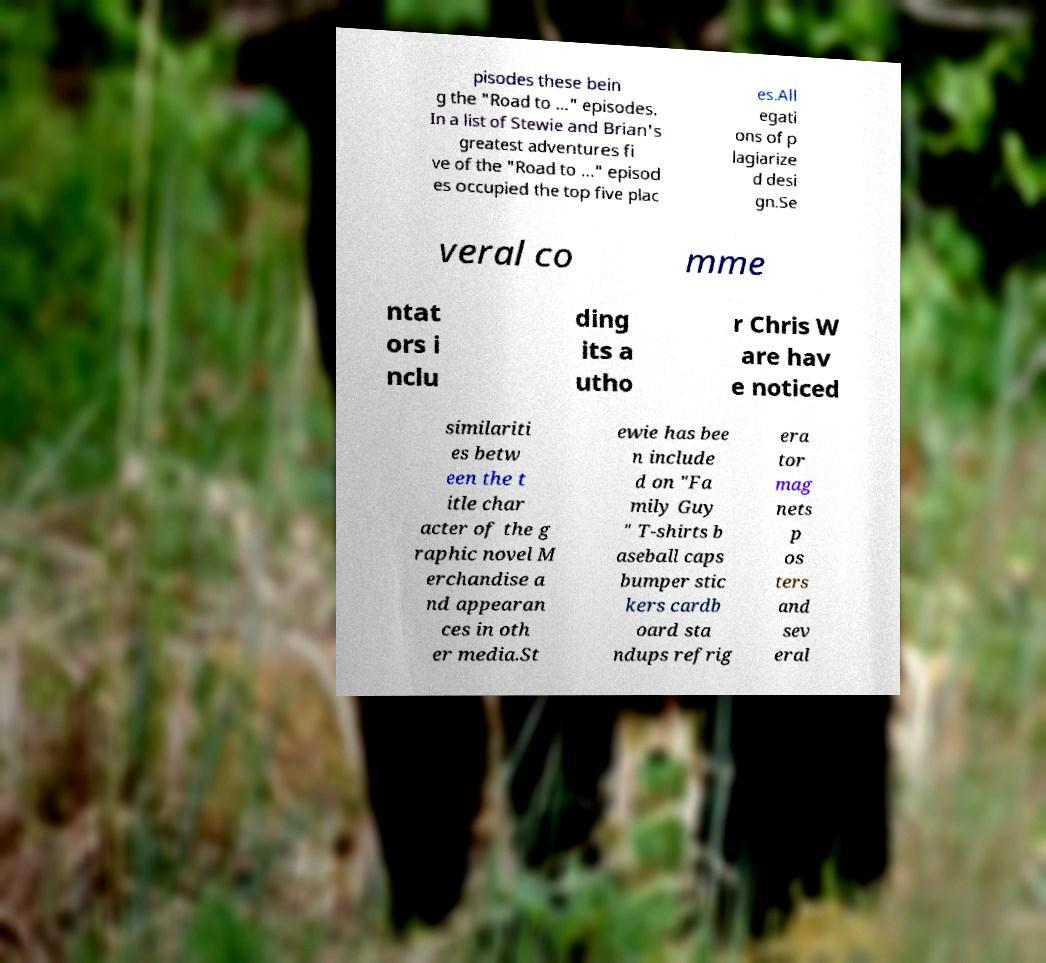What messages or text are displayed in this image? I need them in a readable, typed format. pisodes these bein g the "Road to ..." episodes. In a list of Stewie and Brian's greatest adventures fi ve of the "Road to ..." episod es occupied the top five plac es.All egati ons of p lagiarize d desi gn.Se veral co mme ntat ors i nclu ding its a utho r Chris W are hav e noticed similariti es betw een the t itle char acter of the g raphic novel M erchandise a nd appearan ces in oth er media.St ewie has bee n include d on "Fa mily Guy " T-shirts b aseball caps bumper stic kers cardb oard sta ndups refrig era tor mag nets p os ters and sev eral 